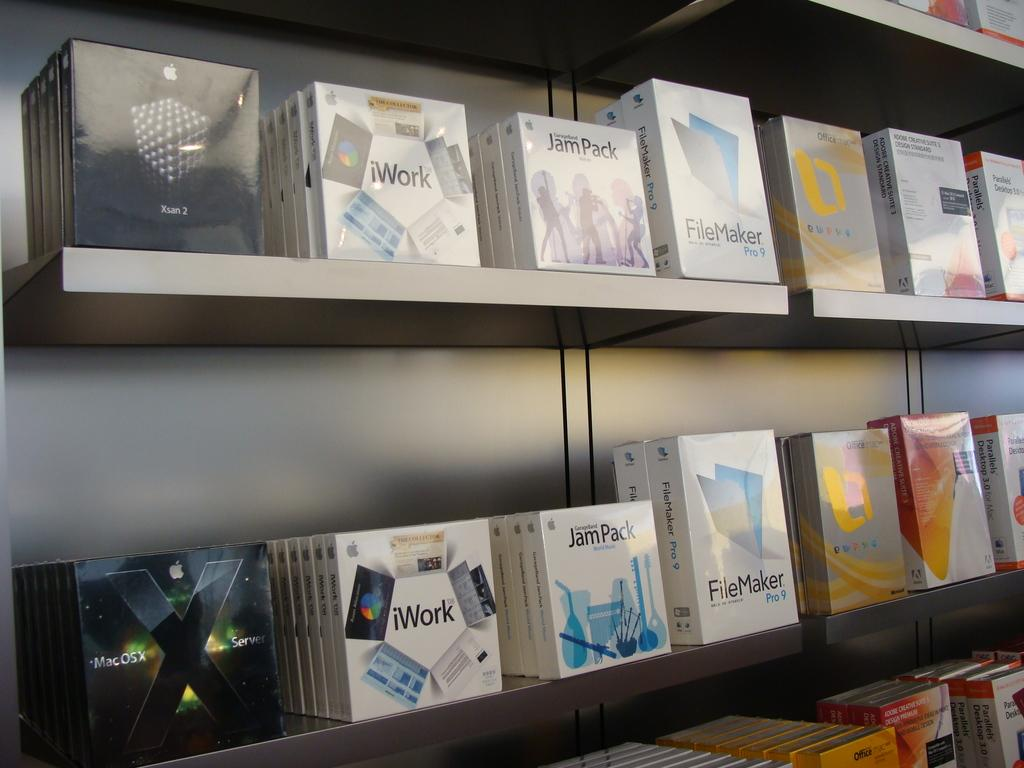<image>
Write a terse but informative summary of the picture. Computer software stores sell many office efficiency platforms including some produced by Apple. 